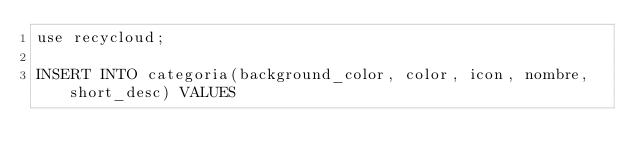<code> <loc_0><loc_0><loc_500><loc_500><_SQL_>use recycloud;

INSERT INTO categoria(background_color, color, icon, nombre, short_desc) VALUES</code> 